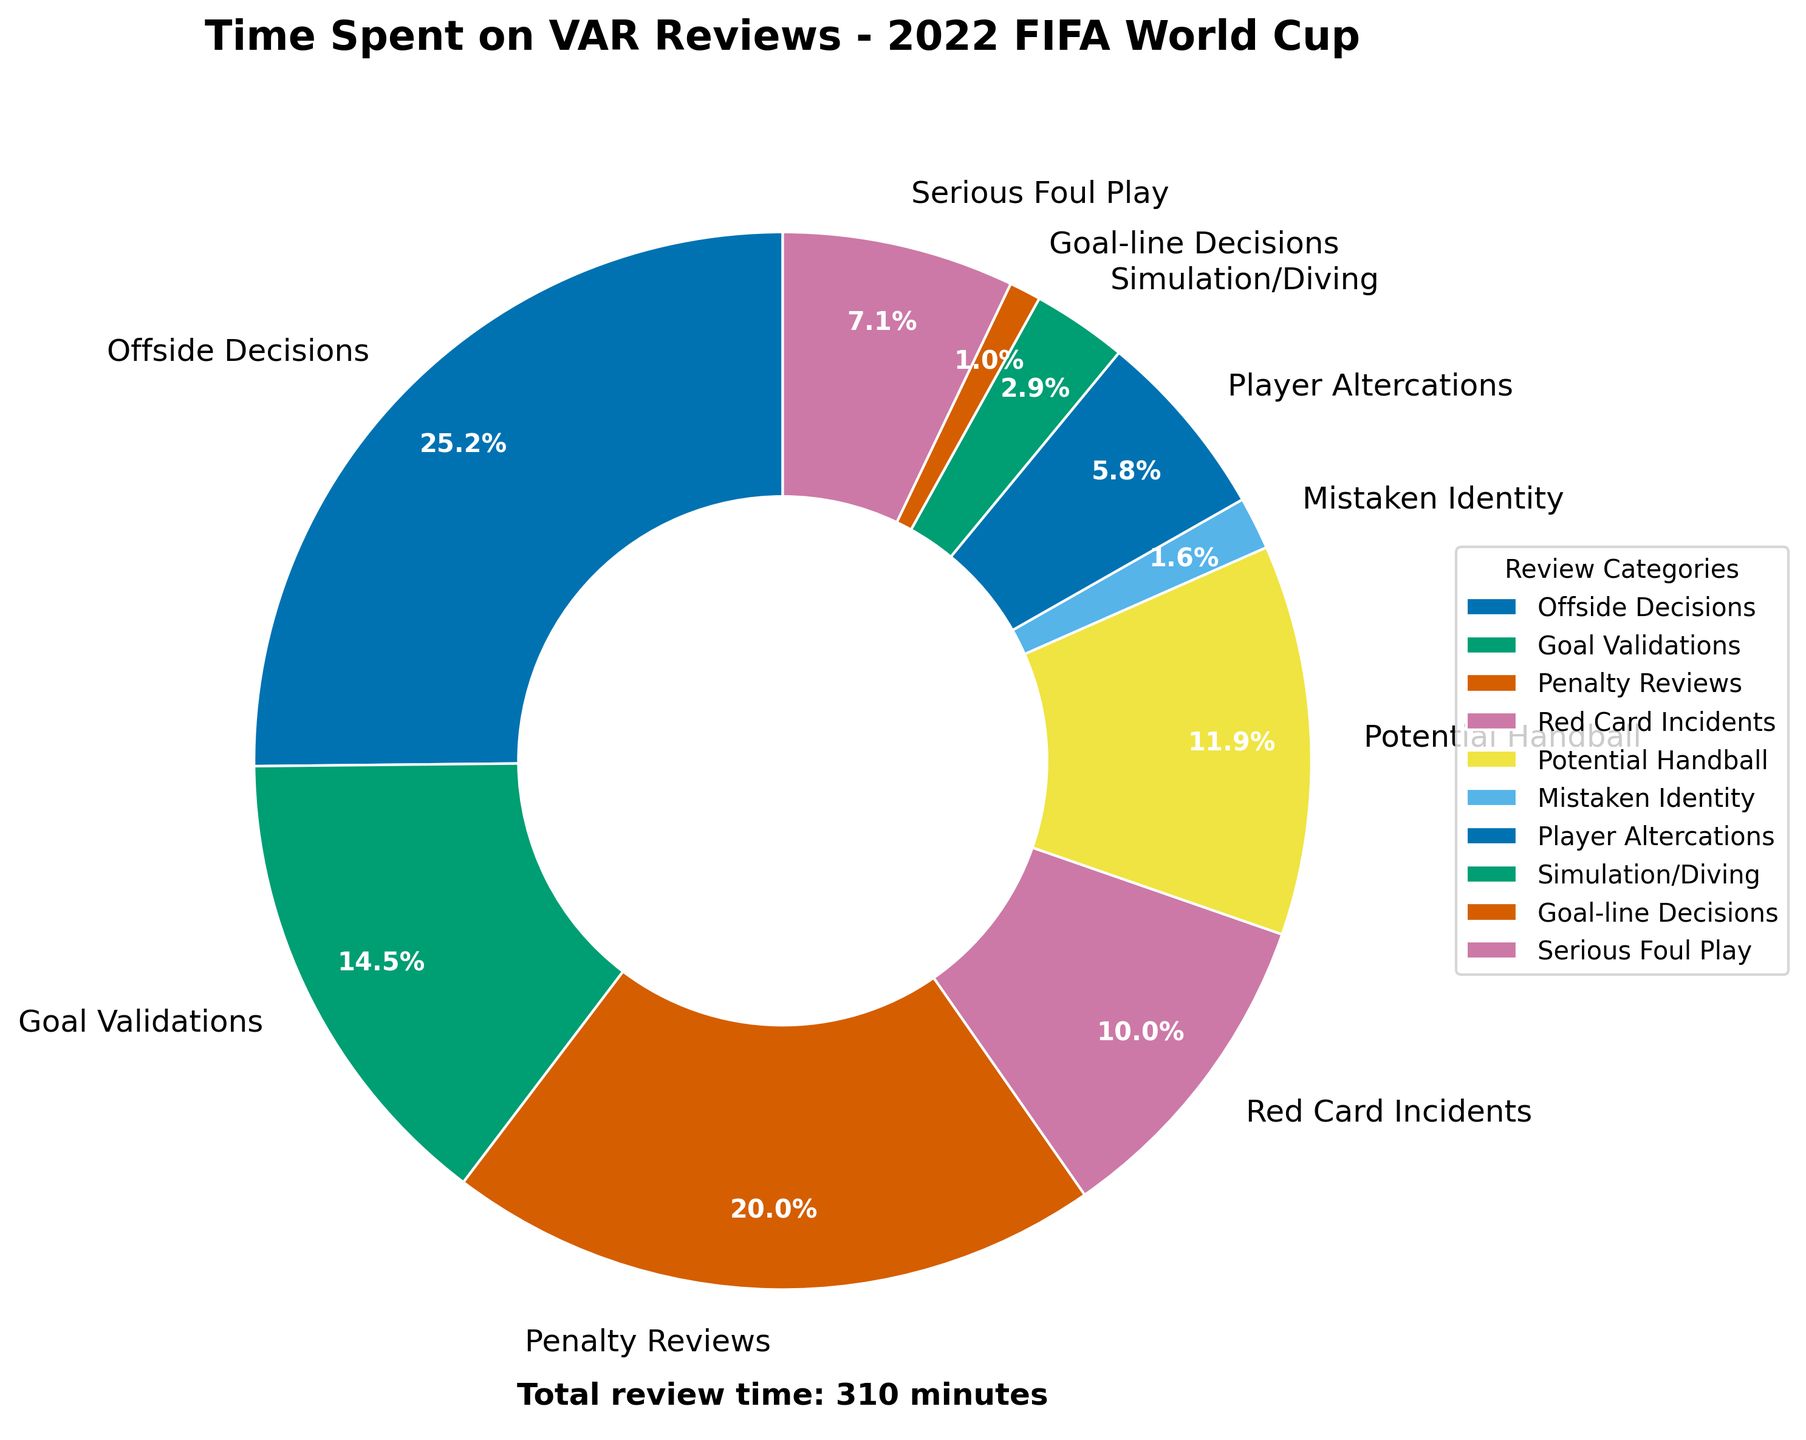Which category took the most time for VAR reviews? The wedges in the pie chart represent the time spent on various categories of VAR reviews. By comparing the sizes of the wedges, we can see that the category "Offside Decisions" occupies the largest portion.
Answer: Offside Decisions How much total time was spent on Goal Validations and Penalty Reviews combined? To find the total time spent on these categories, add the time for Goal Validations (45 minutes) and Penalty Reviews (62 minutes). 45 + 62 = 107 minutes
Answer: 107 minutes Which categories took less time for VAR reviews compared to Red Card Incidents? From the pie chart, Red Card Incidents took 31 minutes. We need to identify categories with times less than 31 minutes: Mistaken Identity (5), Player Altercations (18), Simulation/Diving (9), Goal-line Decisions (3), and Potential Handball (37 but it's slightly more).
Answer: Mistaken Identity, Player Altercations, Simulation/Diving, Goal-line Decisions By what percentage is the time spent on Serious Foul Play reviews smaller than the time spent on Offside Decisions? Time for Serious Foul Play is 22 minutes and for Offside Decisions is 78 minutes. The percentage difference is calculated as ((78 - 22) / 78) * 100. ((78 - 22) / 78) * 100 = 71.79%
Answer: 71.79% What is the total time spent on simulation-related VAR reviews (i.e., Simulation/Diving and Serious Foul Play)? Sum the time spent on Simulation/Diving (9 minutes) and Serious Foul Play (22 minutes). 9 + 22 = 31 minutes
Answer: 31 minutes Compare the time spent on Offside Decisions and Red Card Incidents. What is the ratio of the time spent on Offside Decisions to Red Card Incidents? Time spent on Offside Decisions is 78 minutes, and time on Red Card Incidents is 31 minutes. The ratio is 78:31, which simplifies to 78/31 or approximately 2.52.
Answer: 2.52 Which category has the smallest percentage of total VAR review time? From the pie chart, the smallest wedge corresponds to Goal-line Decisions, which took 3 minutes.
Answer: Goal-line Decisions How much more time is spent on Goal Validations compared to Simulation/Diving? Time for Goal Validations is 45 minutes and for Simulation/Diving is 9 minutes. The difference between them is 45 - 9 = 36 minutes.
Answer: 36 minutes 